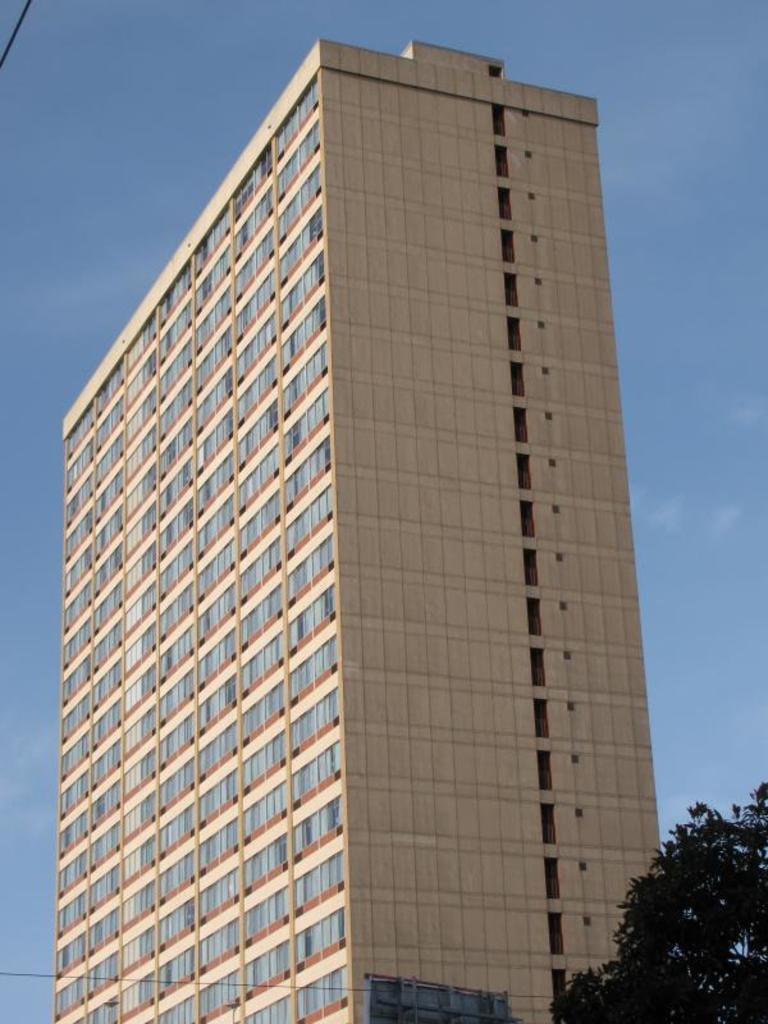In one or two sentences, can you explain what this image depicts? In this image there is a building, beside the building there is a tree. 